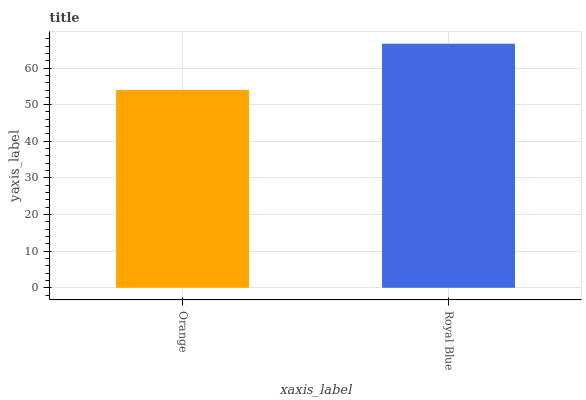Is Orange the minimum?
Answer yes or no. Yes. Is Royal Blue the maximum?
Answer yes or no. Yes. Is Royal Blue the minimum?
Answer yes or no. No. Is Royal Blue greater than Orange?
Answer yes or no. Yes. Is Orange less than Royal Blue?
Answer yes or no. Yes. Is Orange greater than Royal Blue?
Answer yes or no. No. Is Royal Blue less than Orange?
Answer yes or no. No. Is Royal Blue the high median?
Answer yes or no. Yes. Is Orange the low median?
Answer yes or no. Yes. Is Orange the high median?
Answer yes or no. No. Is Royal Blue the low median?
Answer yes or no. No. 